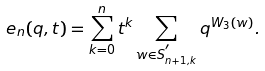Convert formula to latex. <formula><loc_0><loc_0><loc_500><loc_500>e _ { n } ( q , t ) = \sum _ { k = 0 } ^ { n } t ^ { k } \sum _ { w \in S ^ { ^ { \prime } } _ { n + 1 , k } } q ^ { W _ { 3 } ( w ) } .</formula> 